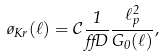<formula> <loc_0><loc_0><loc_500><loc_500>\tau _ { K r } ( \ell ) = \mathcal { C } \frac { 1 } { \alpha D } \frac { \ell _ { p } ^ { 2 } } { G _ { 0 } ( \ell ) } ,</formula> 